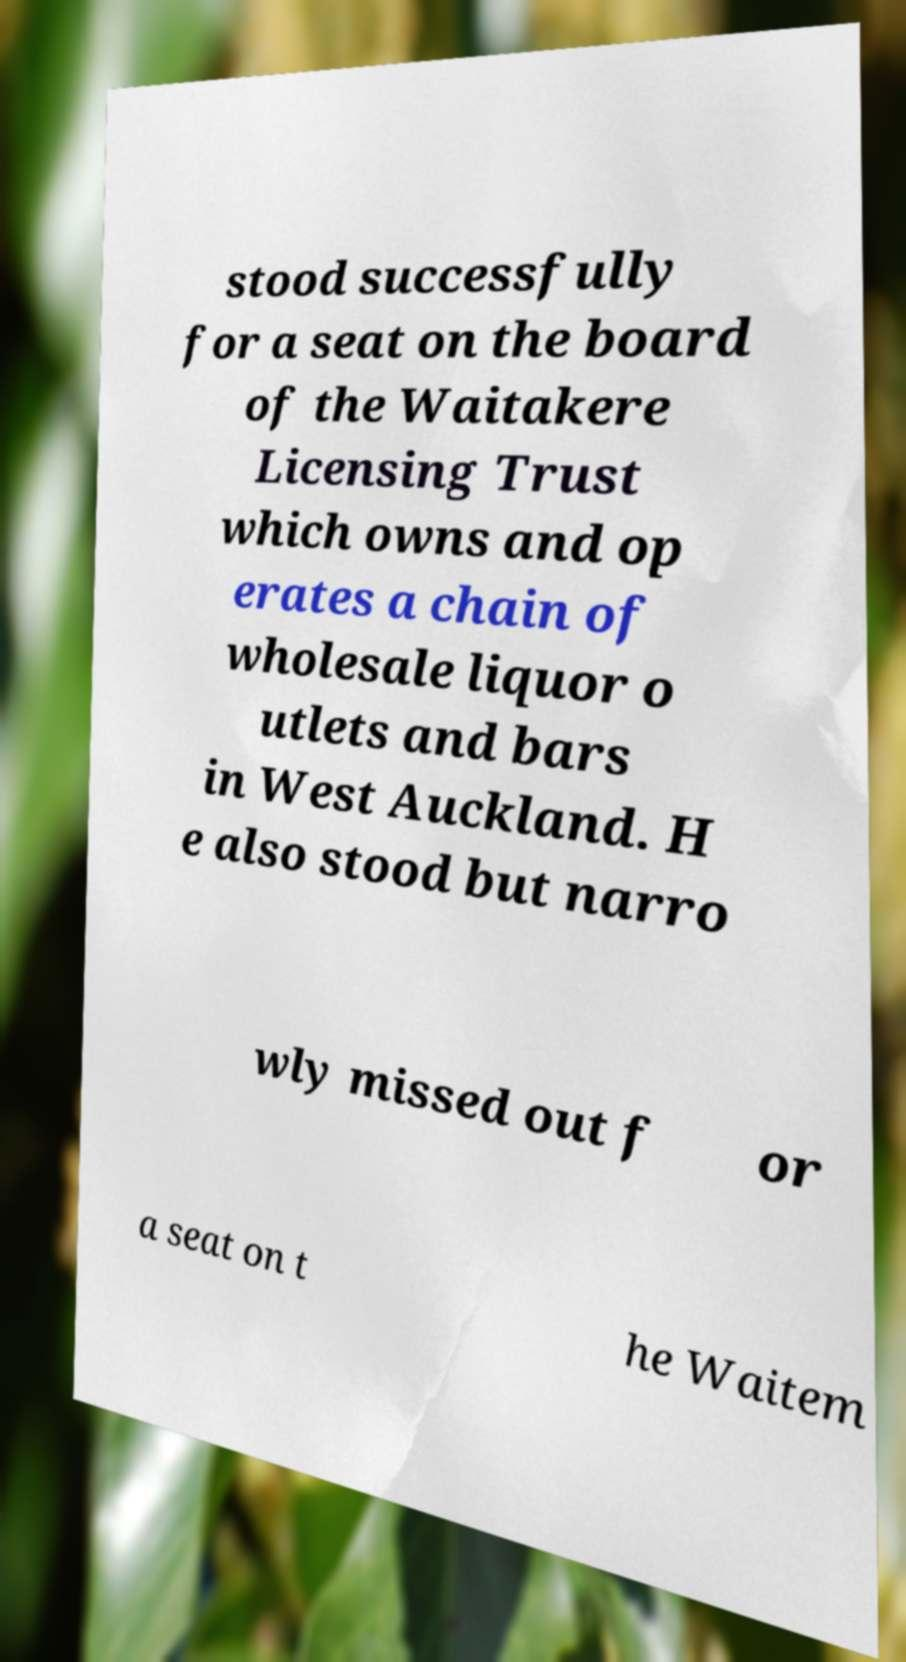What messages or text are displayed in this image? I need them in a readable, typed format. stood successfully for a seat on the board of the Waitakere Licensing Trust which owns and op erates a chain of wholesale liquor o utlets and bars in West Auckland. H e also stood but narro wly missed out f or a seat on t he Waitem 